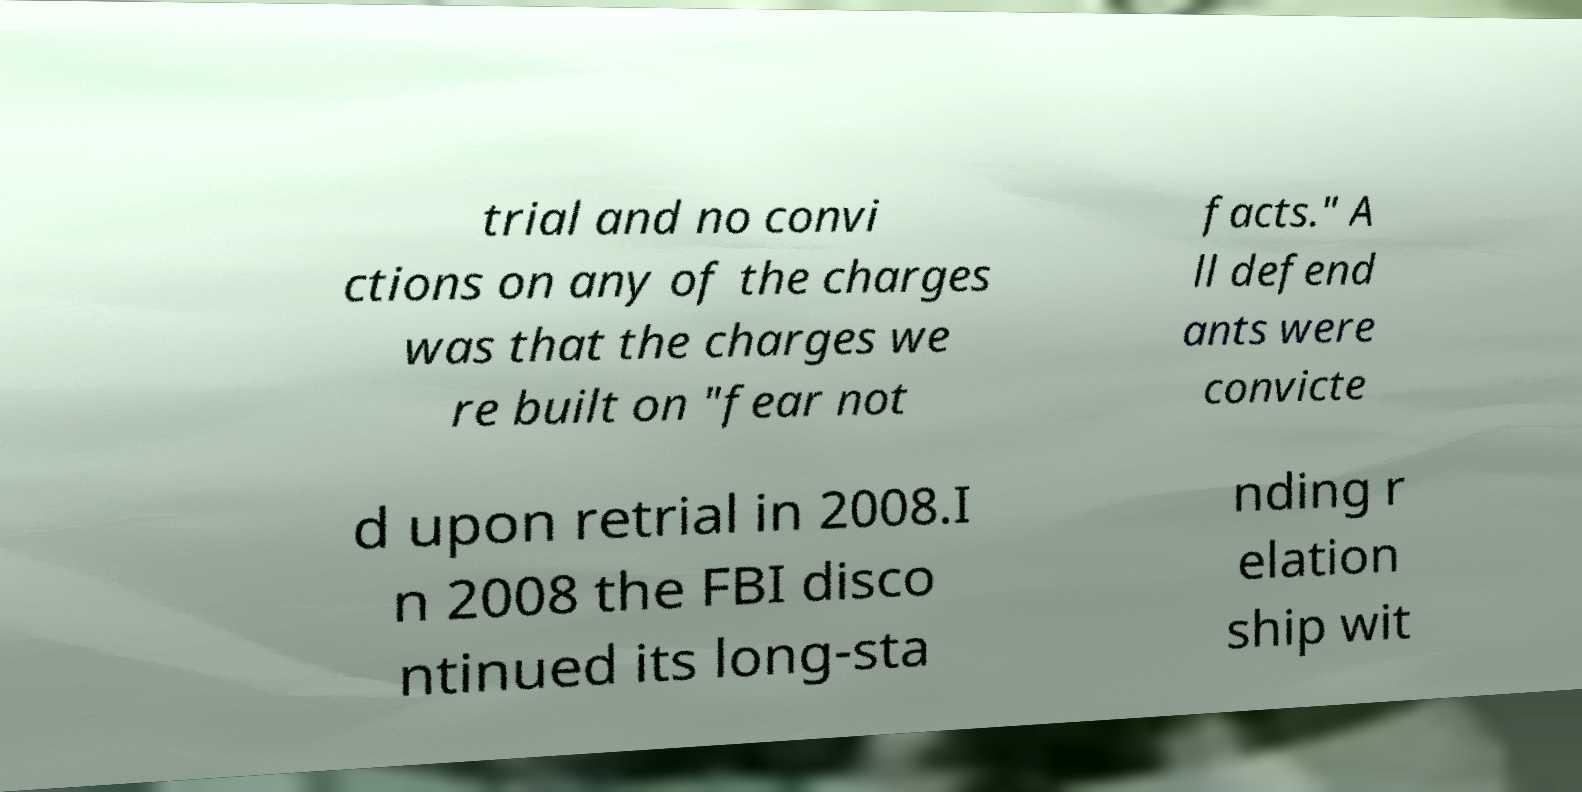For documentation purposes, I need the text within this image transcribed. Could you provide that? trial and no convi ctions on any of the charges was that the charges we re built on "fear not facts." A ll defend ants were convicte d upon retrial in 2008.I n 2008 the FBI disco ntinued its long-sta nding r elation ship wit 